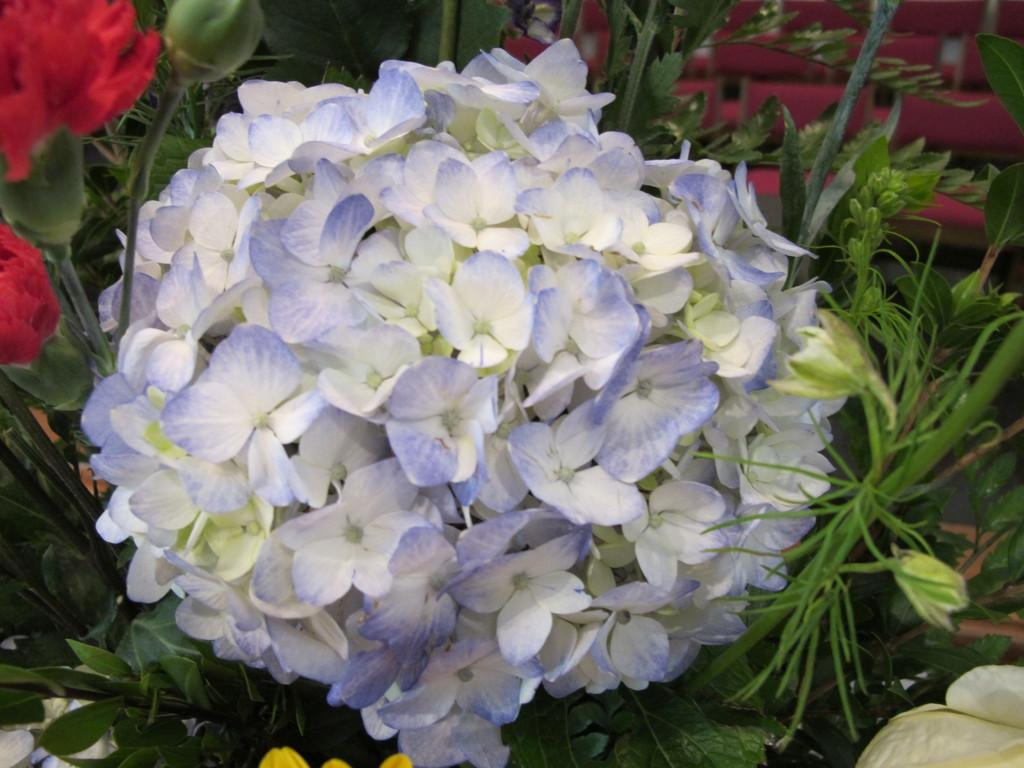What types of plants are present in the image? There are flowers of different colors in the image. What else can be seen in the background of the image? There are leaves visible in the background of the image. What type of vegetable is being stamped in the image? There is no vegetable or stamping activity present in the image; it features flowers and leaves. What causes the flowers to laugh in the image? Flowers do not have the ability to laugh, so this cannot be observed in the image. 